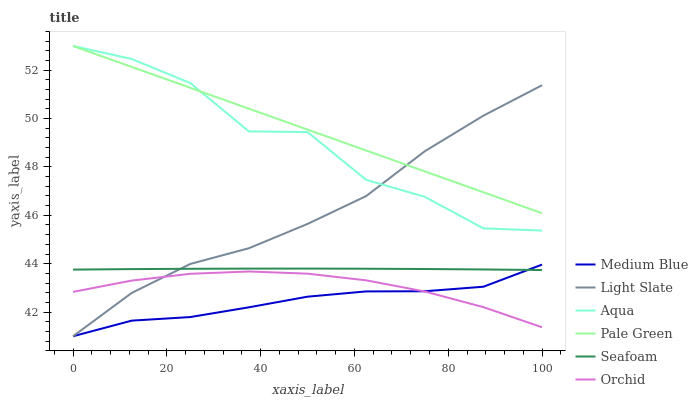Does Medium Blue have the minimum area under the curve?
Answer yes or no. Yes. Does Pale Green have the maximum area under the curve?
Answer yes or no. Yes. Does Aqua have the minimum area under the curve?
Answer yes or no. No. Does Aqua have the maximum area under the curve?
Answer yes or no. No. Is Pale Green the smoothest?
Answer yes or no. Yes. Is Aqua the roughest?
Answer yes or no. Yes. Is Medium Blue the smoothest?
Answer yes or no. No. Is Medium Blue the roughest?
Answer yes or no. No. Does Light Slate have the lowest value?
Answer yes or no. Yes. Does Aqua have the lowest value?
Answer yes or no. No. Does Pale Green have the highest value?
Answer yes or no. Yes. Does Medium Blue have the highest value?
Answer yes or no. No. Is Seafoam less than Pale Green?
Answer yes or no. Yes. Is Pale Green greater than Seafoam?
Answer yes or no. Yes. Does Aqua intersect Pale Green?
Answer yes or no. Yes. Is Aqua less than Pale Green?
Answer yes or no. No. Is Aqua greater than Pale Green?
Answer yes or no. No. Does Seafoam intersect Pale Green?
Answer yes or no. No. 